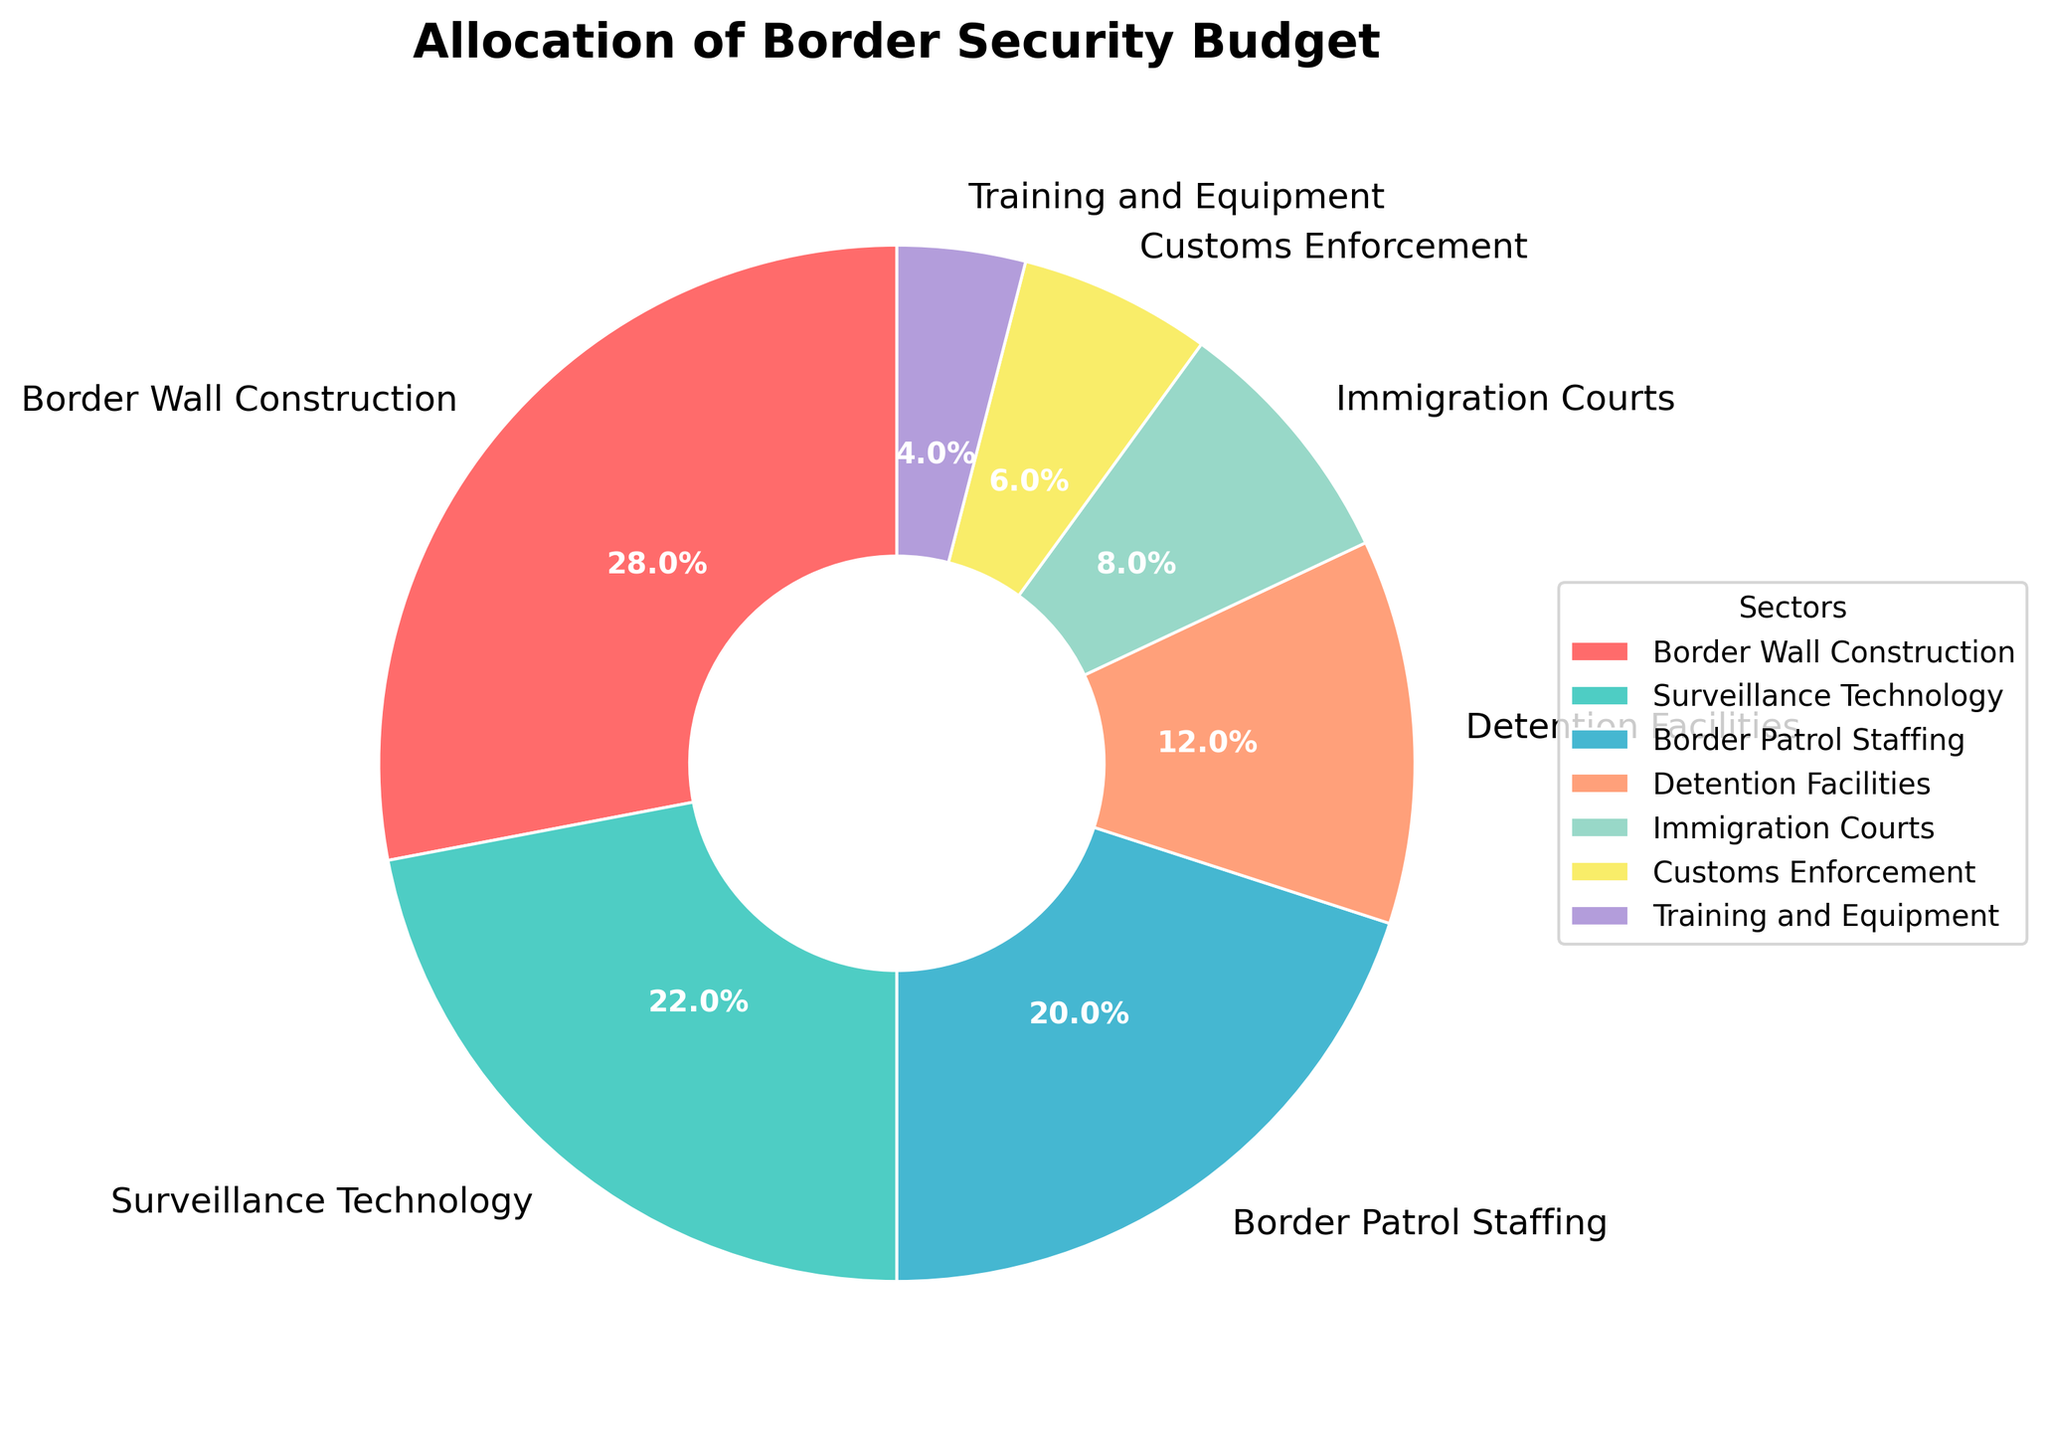What's the largest sector in the allocation? The largest sector is the one with the highest percentage in the pie chart. According to the chart, "Border Wall Construction" has the highest allocation at 28%.
Answer: Border Wall Construction What's the total budget allocation for Surveillance Technology and Border Patrol Staffing? To find the total budget allocation for these two sectors, add the percentages for "Surveillance Technology" (22%) and "Border Patrol Staffing" (20%): 22% + 20% = 42%.
Answer: 42% Which sector has a smaller allocation: Immigration Courts or Detention Facilities? Compare the percentages for "Immigration Courts" (8%) and "Detention Facilities" (12%). Since 8% is smaller than 12%, "Immigration Courts" has a smaller allocation.
Answer: Immigration Courts What is the combined allocation for all sectors related to personnel and infrastructure? (Border Patrol Staffing, Detention Facilities, Immigration Courts, and Training and Equipment) Add the allocations for "Border Patrol Staffing" (20%), "Detention Facilities" (12%), "Immigration Courts" (8%), and "Training and Equipment" (4%): 20% + 12% + 8% + 4% = 44%.
Answer: 44% Which sectors have an allocation of more than 20%? Sectors with more than 20% allocation are those with percentages greater than 20% in the pie chart. "Border Wall Construction" (28%) and "Surveillance Technology" (22%) both exceed 20%.
Answer: Border Wall Construction and Surveillance Technology What percentage more is allocated to Border Wall Construction compared to Customs Enforcement? Subtract the allocation for "Customs Enforcement" (6%) from the allocation for "Border Wall Construction" (28%): 28% - 6% = 22%.
Answer: 22% Which visual attribute represents the Detention Facilities sector? The Detention Facilities sector is represented by a segment in the pie chart. Look for the segment with text "Detention Facilities" and a percentage label of 12%. It's the wedge with the apricot color.
Answer: Apricot segment with 12% Is the allocation for Training and Equipment more or less than half of the allocation for Immigration Courts? The allocation for Training and Equipment is 4%, and for Immigration Courts, it is 8%. Since 4% is exactly half of 8%, the allocation for Training and Equipment is equal to half of that for Immigration Courts.
Answer: Equal to half 